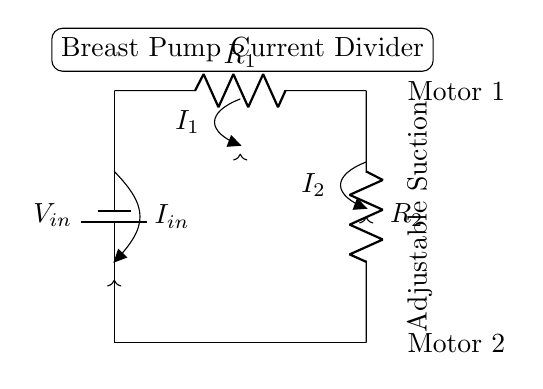What is the input voltage for this circuit? The input voltage is indicated as V_in in the diagram, but the actual numeric value is not provided in the circuit.
Answer: V_in What are the two resistors in this circuit? The two resistors are labeled R_1 and R_2 in the circuit diagram, and are placed in parallel as part of the current divider function.
Answer: R_1 and R_2 How many motors are connected in this circuit? There are two motors indicated in the circuit diagram, one associated with each end of the resistor network.
Answer: Two What is the relationship between I_in, I_1, and I_2? According to the current divider rule, the total current I_in entering the parallel resistors is equal to the sum of the currents I_1 and I_2 flowing through R_1 and R_2 respectively.
Answer: I_in = I_1 + I_2 If R_1 is half the resistance of R_2, what can be said about the currents I_1 and I_2? Based on the current divider principle, if R_1 is lower than R_2, a higher proportion of I_in will flow through R_1, making I_1 greater than I_2.
Answer: I_1 > I_2 What function does the circuit provide for the breast pump? The circuit serves to create an adjustable suction power by dividing the current appropriately to the motors involved.
Answer: Adjustable suction 